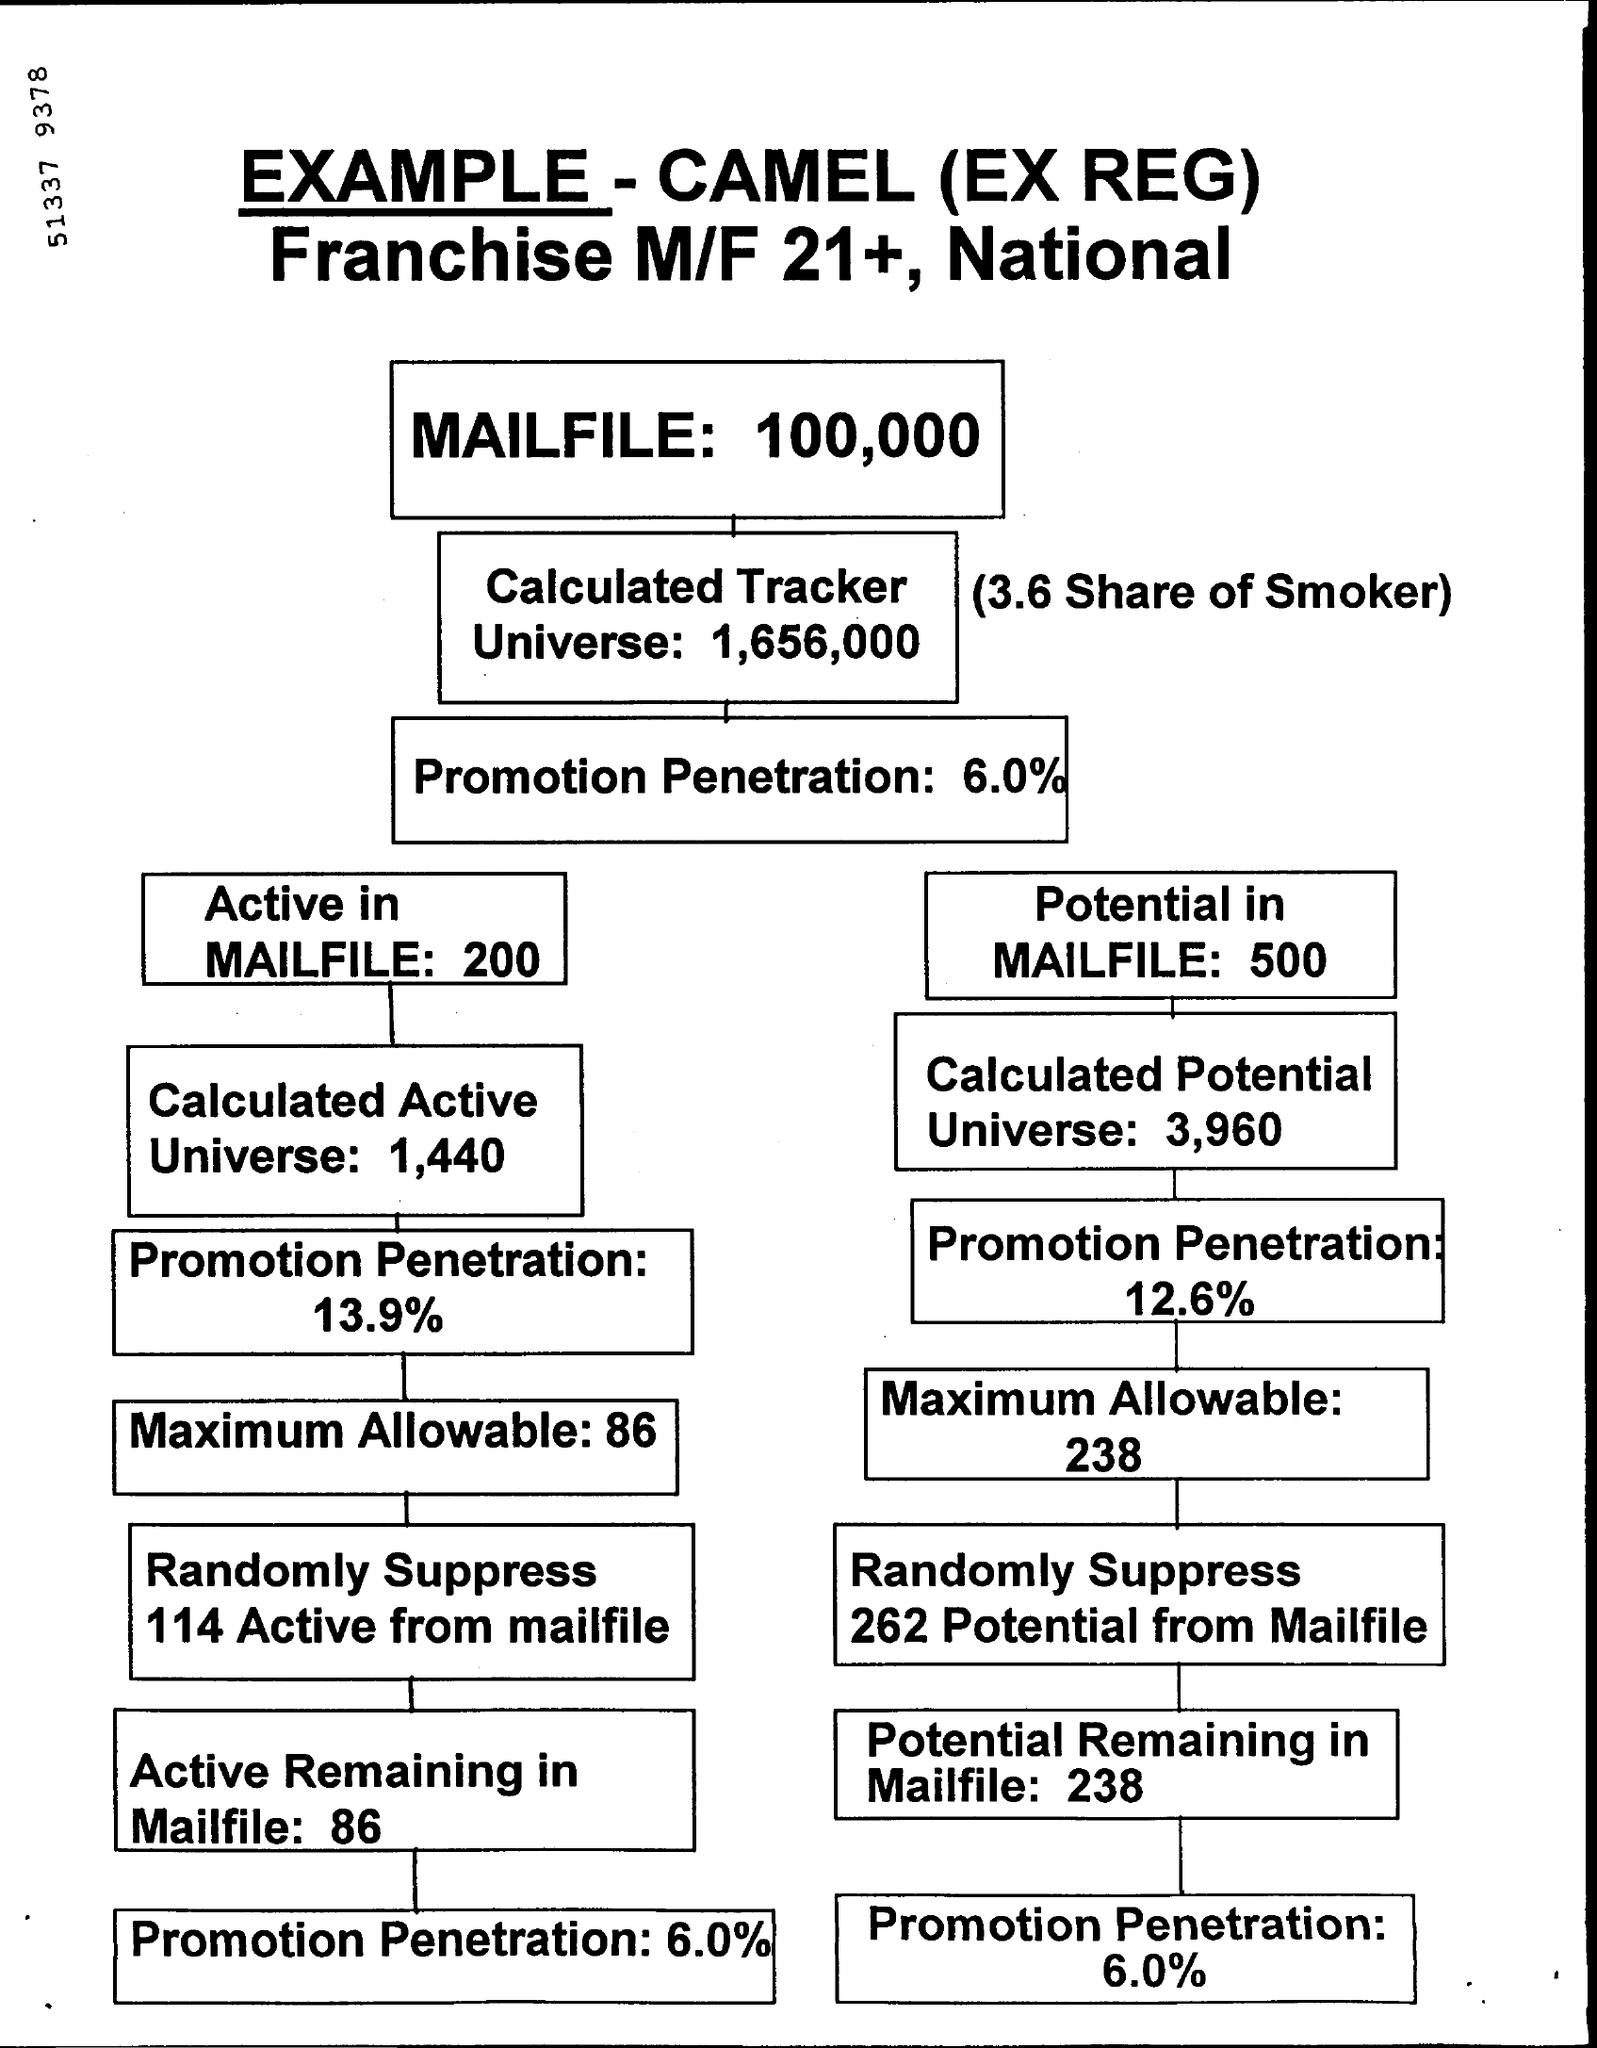What is the number for the maximum allowable in active mailfile?
Your answer should be very brief. 86. What is the number for the potential remaining in mail file?
Offer a very short reply. 238. 